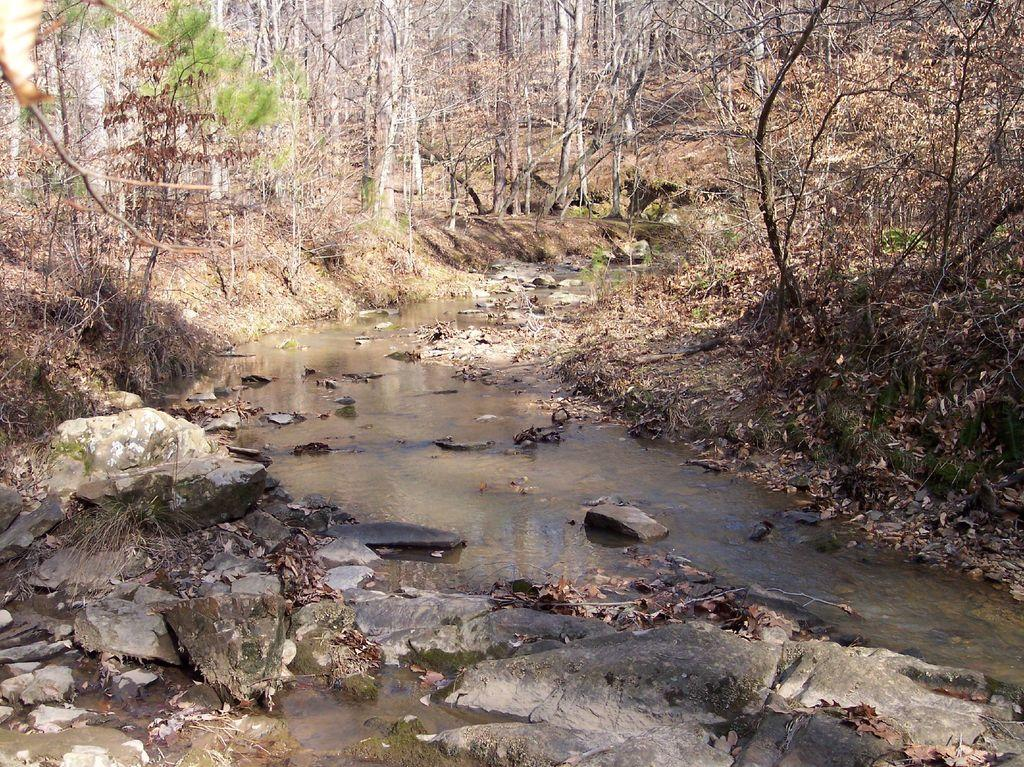What is the main subject of the image? The image depicts a canal. What is happening to the water in the canal? Water is flowing in the canal. Are there any natural elements present in the image? Yes, there are rocks and trees visible in the image. What type of religion is practiced by the things in the image? There are no things or religious practices depicted in the image; it features a canal with flowing water and natural elements. 